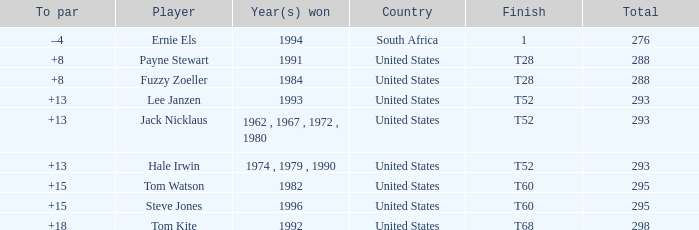Who is the player from the United States with a total less than 293 and won in 1984? Fuzzy Zoeller. 